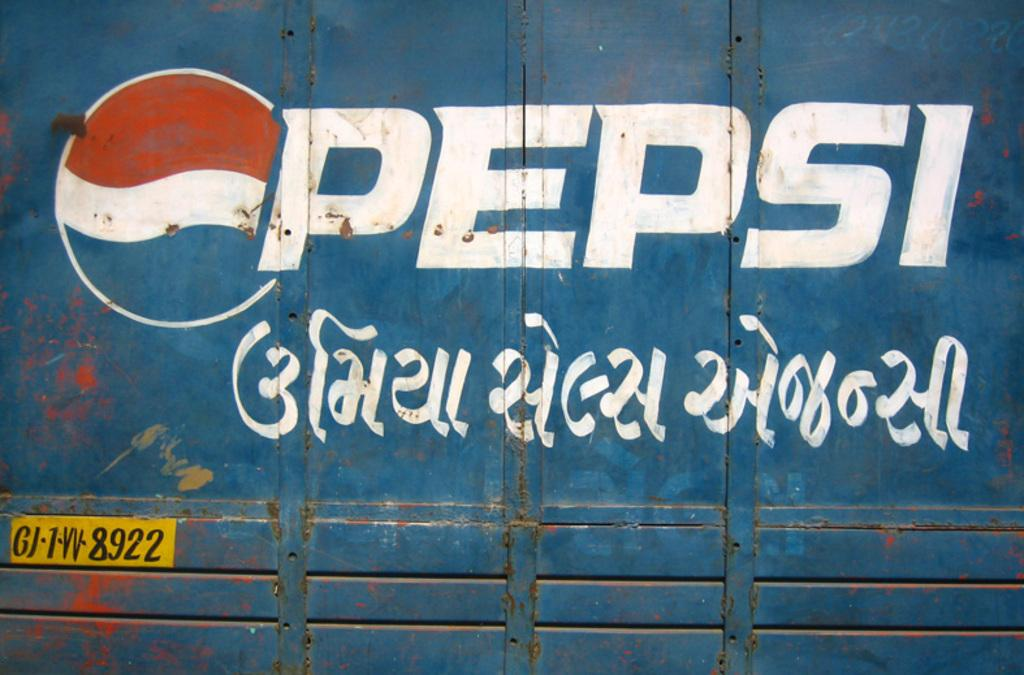<image>
Render a clear and concise summary of the photo. the word Pepsi is on the front of a truck 